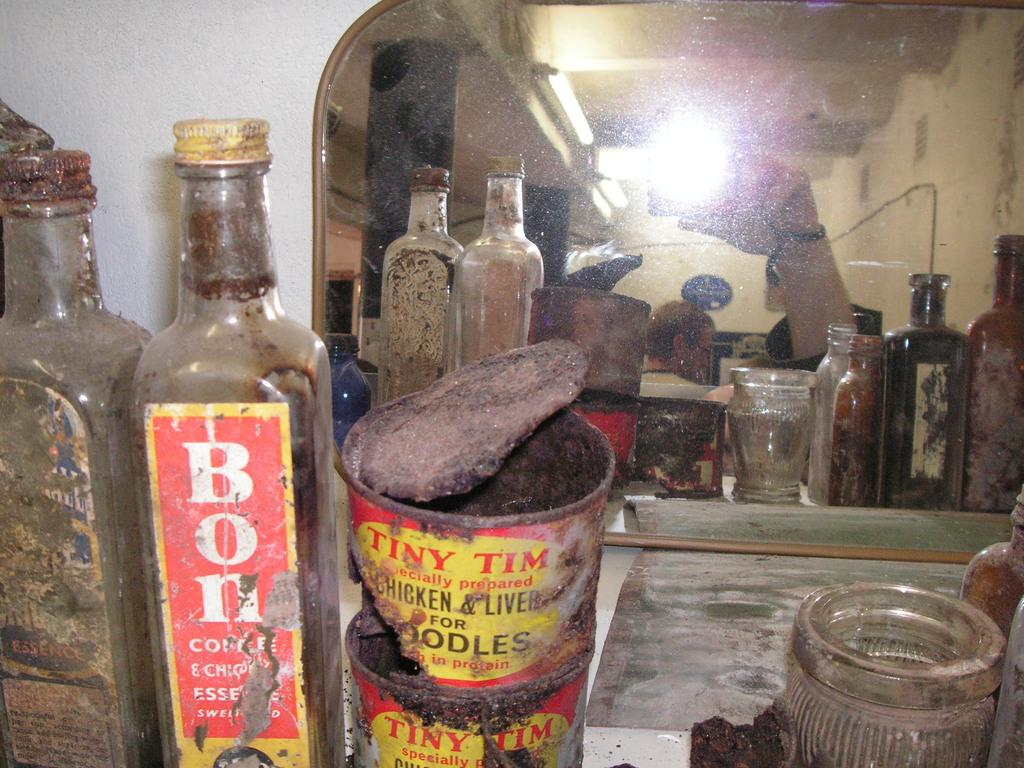Provide a one-sentence caption for the provided image. An old collection of jars and tins including a tin of chicken liver. 